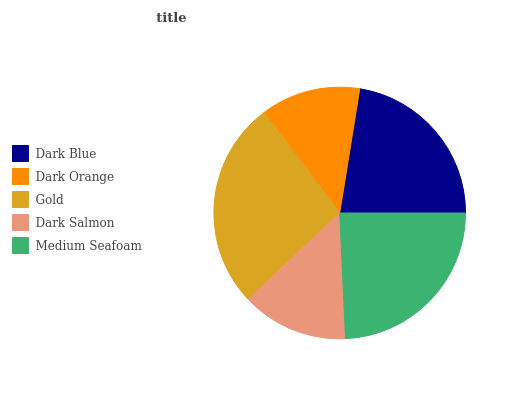Is Dark Orange the minimum?
Answer yes or no. Yes. Is Gold the maximum?
Answer yes or no. Yes. Is Gold the minimum?
Answer yes or no. No. Is Dark Orange the maximum?
Answer yes or no. No. Is Gold greater than Dark Orange?
Answer yes or no. Yes. Is Dark Orange less than Gold?
Answer yes or no. Yes. Is Dark Orange greater than Gold?
Answer yes or no. No. Is Gold less than Dark Orange?
Answer yes or no. No. Is Dark Blue the high median?
Answer yes or no. Yes. Is Dark Blue the low median?
Answer yes or no. Yes. Is Dark Salmon the high median?
Answer yes or no. No. Is Gold the low median?
Answer yes or no. No. 